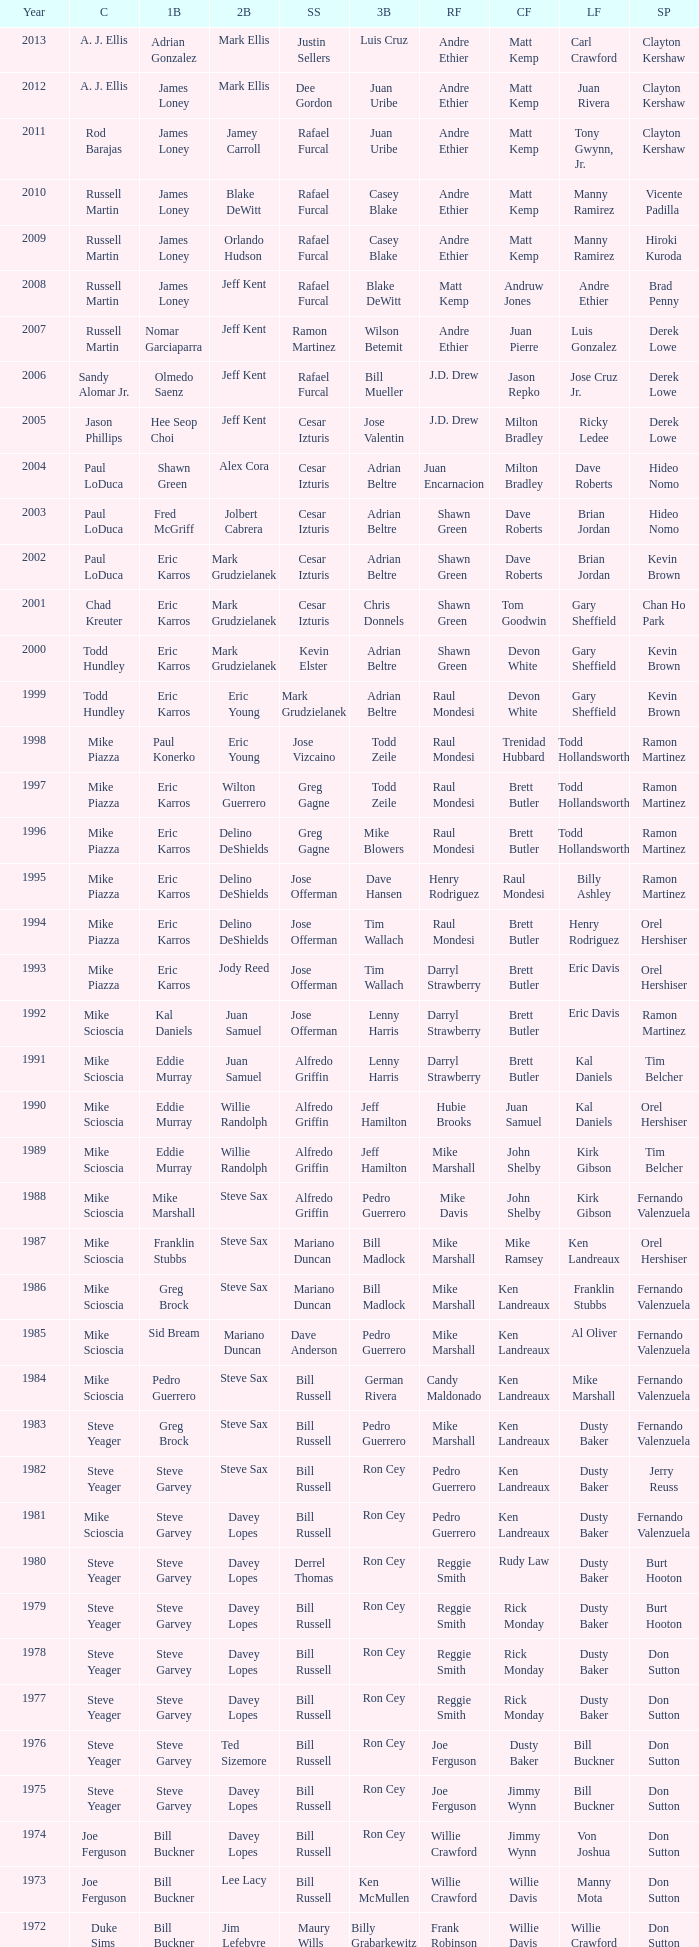Who was the SS when jim lefebvre was at 2nd, willie davis at CF, and don drysdale was the SP. Maury Wills. 